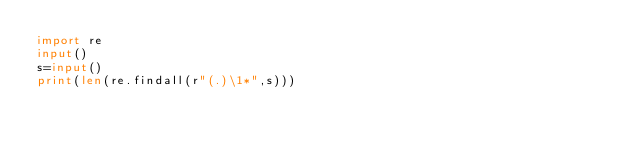Convert code to text. <code><loc_0><loc_0><loc_500><loc_500><_Python_>import re
input()
s=input()
print(len(re.findall(r"(.)\1*",s)))</code> 